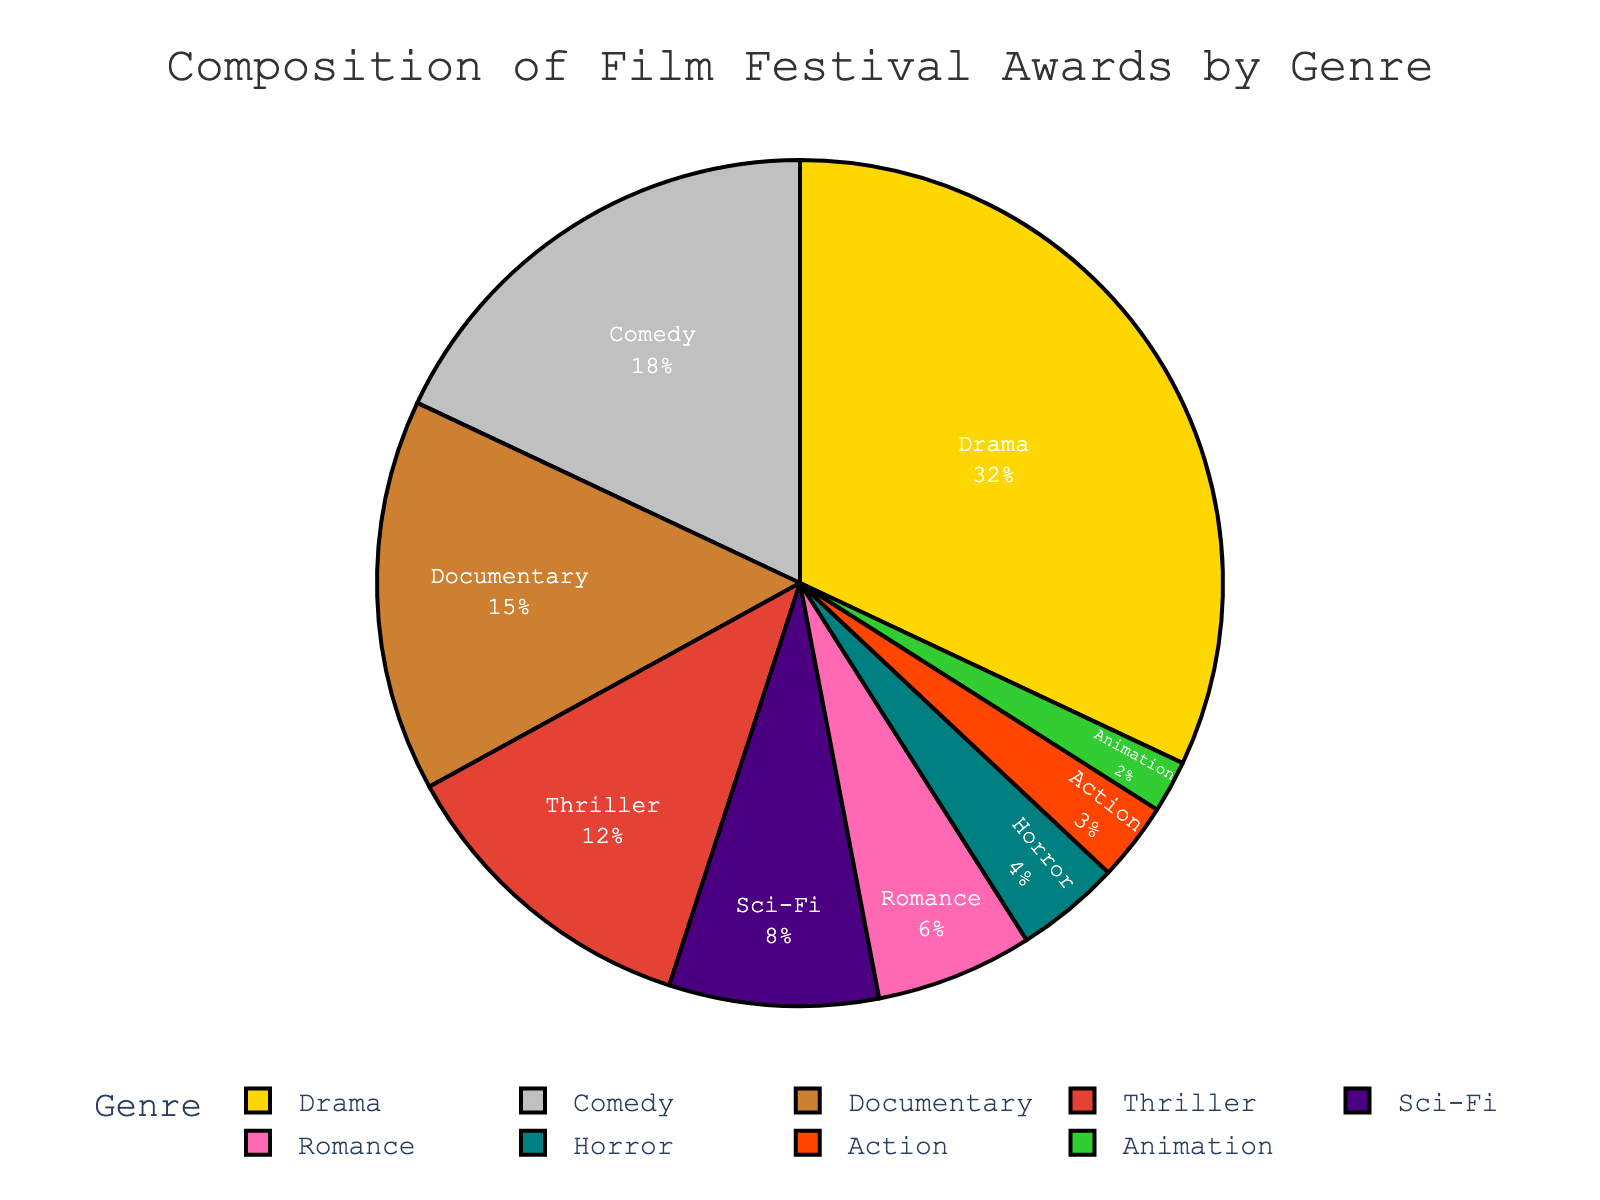What percentage of awards are given to genres other than Drama and Comedy? The percentage for Drama is 32% and for Comedy is 18%. Summing them up gives 32% + 18% = 50%. Subtracting this from 100% gives 100% - 50% = 50%.
Answer: 50% Which genre receives the highest percentage of awards? By inspecting the pie chart, the largest segment represents Drama at 32%.
Answer: Drama Is the percentage of awards for Sci-Fi greater than or equal to that for Romance? According to the pie chart, Sci-Fi has 8% and Romance has 6%. Since 8% is greater than 6%, Sci-Fi has a greater percentage.
Answer: Yes How much larger is the percentage of Documentary awards compared to Horror awards? Documentary has 15% and Horror has 4%. The difference is 15% - 4% = 11%.
Answer: 11% List the genres that constitute less than 10% of the awards. According to the pie chart, these genres are Sci-Fi (8%), Romance (6%), Horror (4%), Action (3%), and Animation (2%).
Answer: Sci-Fi, Romance, Horror, Action, Animation What is the combined percentage of awards for genres Thriller and Sci-Fi? Thriller has 12% and Sci-Fi has 8%. Adding these percentages gives 12% + 8% = 20%.
Answer: 20% Which genre has the smallest percentage of awards? The smallest segment in the pie chart corresponds to Animation at 2%.
Answer: Animation Do Comedy and Romance together constitute a larger percentage than Documentary? Comedy is 18% and Romance is 6%. Combined, they constitute 18% + 6% = 24%, which is larger than Documentary at 15%.
Answer: Yes How many times larger is the percentage of Drama awards compared to Action awards? Drama has 32% and Action has 3%. Dividing these, we get 32% / 3% ≈ 10.67.
Answer: Approximately 10.67 times If you were to exclude Drama from the chart, what would be the new percentage of Comedy? Drama is 32%, so the remaining 100% - 32% = 68%. Comedy is originally 18%. The new percentage is (18/68) * 100 ≈ 26.47%.
Answer: Approximately 26.47% 